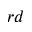Convert formula to latex. <formula><loc_0><loc_0><loc_500><loc_500>^ { r d }</formula> 